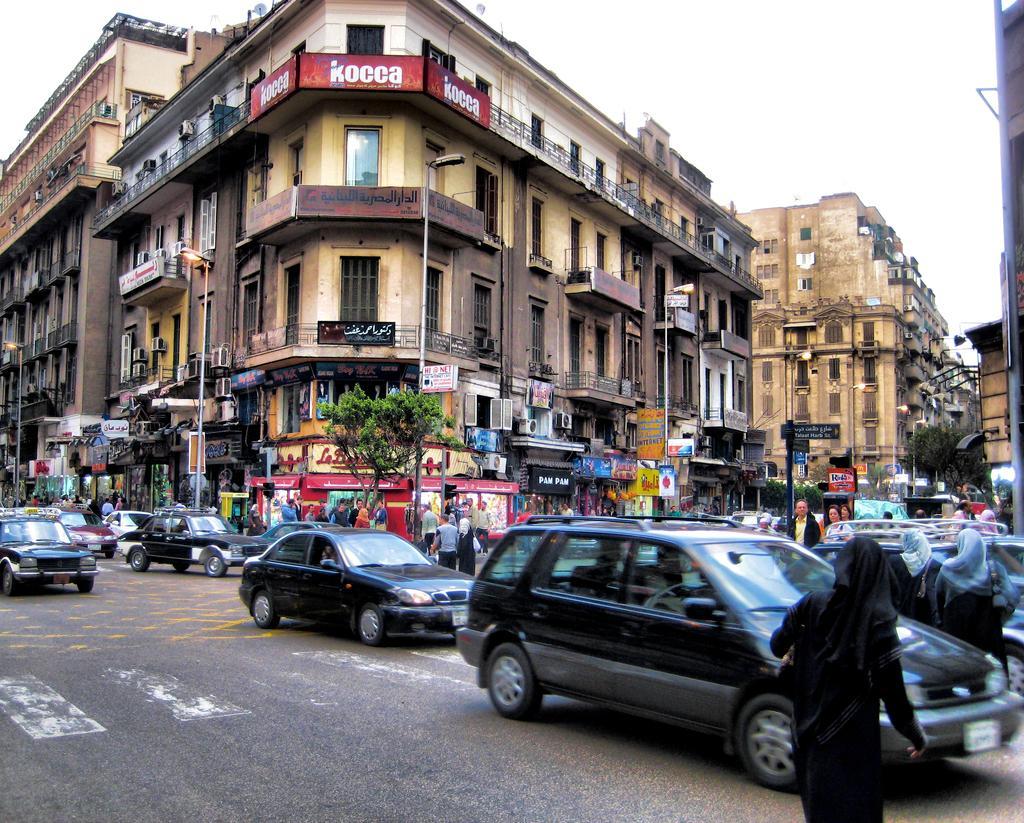Could you give a brief overview of what you see in this image? In the image we can see there are many buildings and these are the windows of the building. Here we can even see there are vehicles on the road. There are even people wearing clothes. Here we can see a road and a white sky. 